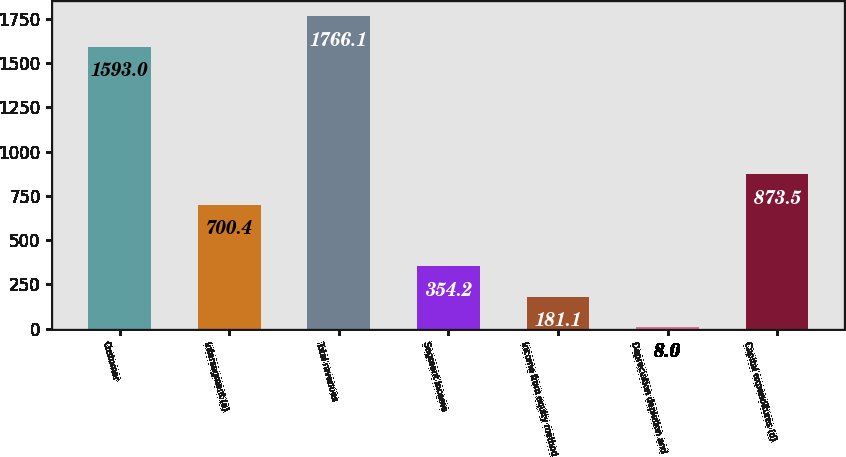<chart> <loc_0><loc_0><loc_500><loc_500><bar_chart><fcel>Customer<fcel>Intersegment (a)<fcel>Total revenues<fcel>Segment income<fcel>Income from equity method<fcel>Depreciation depletion and<fcel>Capital expenditures (d)<nl><fcel>1593<fcel>700.4<fcel>1766.1<fcel>354.2<fcel>181.1<fcel>8<fcel>873.5<nl></chart> 